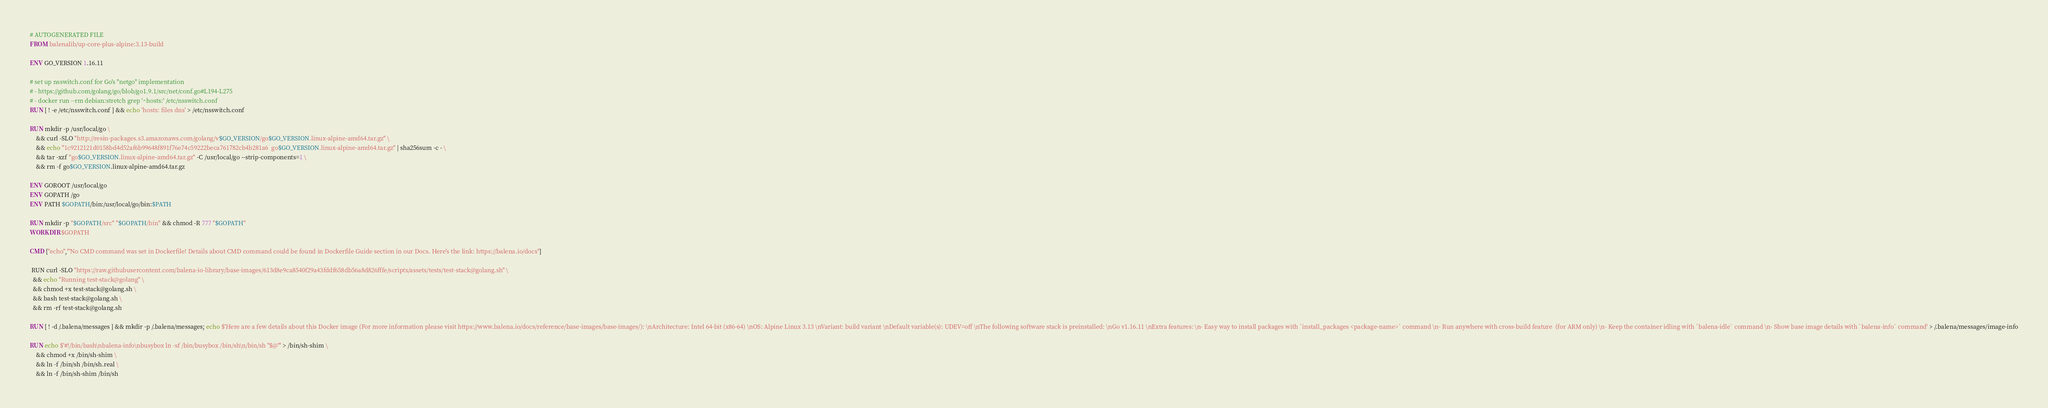Convert code to text. <code><loc_0><loc_0><loc_500><loc_500><_Dockerfile_># AUTOGENERATED FILE
FROM balenalib/up-core-plus-alpine:3.13-build

ENV GO_VERSION 1.16.11

# set up nsswitch.conf for Go's "netgo" implementation
# - https://github.com/golang/go/blob/go1.9.1/src/net/conf.go#L194-L275
# - docker run --rm debian:stretch grep '^hosts:' /etc/nsswitch.conf
RUN [ ! -e /etc/nsswitch.conf ] && echo 'hosts: files dns' > /etc/nsswitch.conf

RUN mkdir -p /usr/local/go \
	&& curl -SLO "http://resin-packages.s3.amazonaws.com/golang/v$GO_VERSION/go$GO_VERSION.linux-alpine-amd64.tar.gz" \
	&& echo "1c9212121d0158bd4d52af6b99648f891f76e74c59222beca761782cb4b281a6  go$GO_VERSION.linux-alpine-amd64.tar.gz" | sha256sum -c - \
	&& tar -xzf "go$GO_VERSION.linux-alpine-amd64.tar.gz" -C /usr/local/go --strip-components=1 \
	&& rm -f go$GO_VERSION.linux-alpine-amd64.tar.gz

ENV GOROOT /usr/local/go
ENV GOPATH /go
ENV PATH $GOPATH/bin:/usr/local/go/bin:$PATH

RUN mkdir -p "$GOPATH/src" "$GOPATH/bin" && chmod -R 777 "$GOPATH"
WORKDIR $GOPATH

CMD ["echo","'No CMD command was set in Dockerfile! Details about CMD command could be found in Dockerfile Guide section in our Docs. Here's the link: https://balena.io/docs"]

 RUN curl -SLO "https://raw.githubusercontent.com/balena-io-library/base-images/613d8e9ca8540f29a43fddf658db56a8d826fffe/scripts/assets/tests/test-stack@golang.sh" \
  && echo "Running test-stack@golang" \
  && chmod +x test-stack@golang.sh \
  && bash test-stack@golang.sh \
  && rm -rf test-stack@golang.sh 

RUN [ ! -d /.balena/messages ] && mkdir -p /.balena/messages; echo $'Here are a few details about this Docker image (For more information please visit https://www.balena.io/docs/reference/base-images/base-images/): \nArchitecture: Intel 64-bit (x86-64) \nOS: Alpine Linux 3.13 \nVariant: build variant \nDefault variable(s): UDEV=off \nThe following software stack is preinstalled: \nGo v1.16.11 \nExtra features: \n- Easy way to install packages with `install_packages <package-name>` command \n- Run anywhere with cross-build feature  (for ARM only) \n- Keep the container idling with `balena-idle` command \n- Show base image details with `balena-info` command' > /.balena/messages/image-info

RUN echo $'#!/bin/bash\nbalena-info\nbusybox ln -sf /bin/busybox /bin/sh\n/bin/sh "$@"' > /bin/sh-shim \
	&& chmod +x /bin/sh-shim \
	&& ln -f /bin/sh /bin/sh.real \
	&& ln -f /bin/sh-shim /bin/sh</code> 